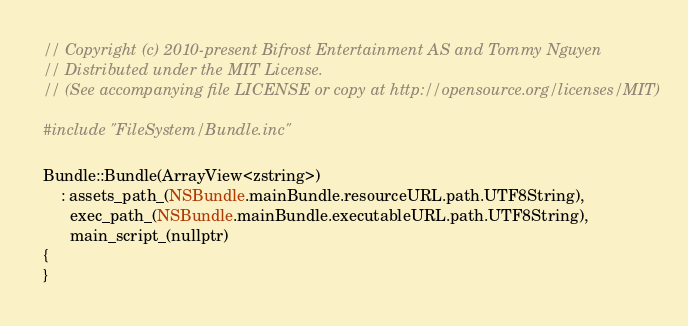<code> <loc_0><loc_0><loc_500><loc_500><_ObjectiveC_>// Copyright (c) 2010-present Bifrost Entertainment AS and Tommy Nguyen
// Distributed under the MIT License.
// (See accompanying file LICENSE or copy at http://opensource.org/licenses/MIT)

#include "FileSystem/Bundle.inc"

Bundle::Bundle(ArrayView<zstring>)
    : assets_path_(NSBundle.mainBundle.resourceURL.path.UTF8String),
      exec_path_(NSBundle.mainBundle.executableURL.path.UTF8String),
      main_script_(nullptr)
{
}
</code> 